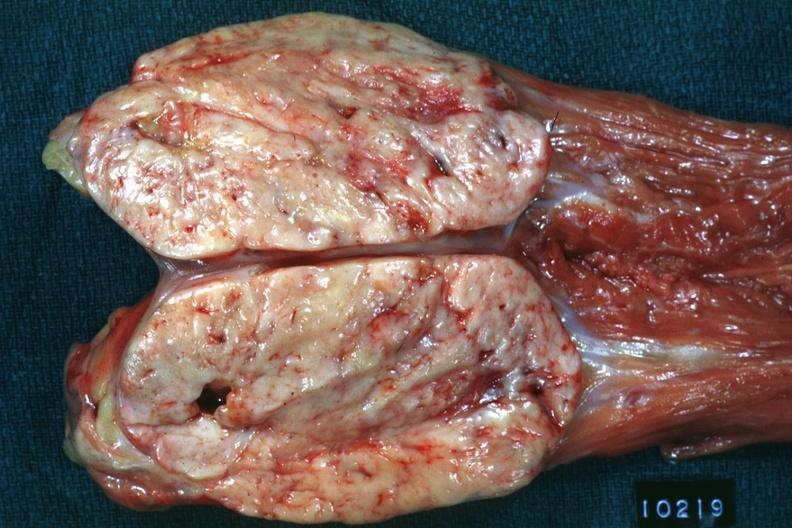how does opened muscle psoa natural color ovoid typical sarcoma?
Answer the question using a single word or phrase. Large 